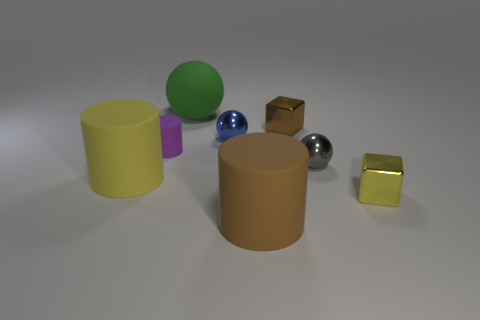Subtract all purple cylinders. How many cylinders are left? 2 Subtract 1 cylinders. How many cylinders are left? 2 Add 1 red rubber objects. How many objects exist? 9 Subtract all cylinders. How many objects are left? 5 Subtract all green cylinders. Subtract all blue blocks. How many cylinders are left? 3 Subtract all small brown metal blocks. Subtract all green objects. How many objects are left? 6 Add 6 tiny blue shiny things. How many tiny blue shiny things are left? 7 Add 8 small cyan cylinders. How many small cyan cylinders exist? 8 Subtract 1 blue spheres. How many objects are left? 7 